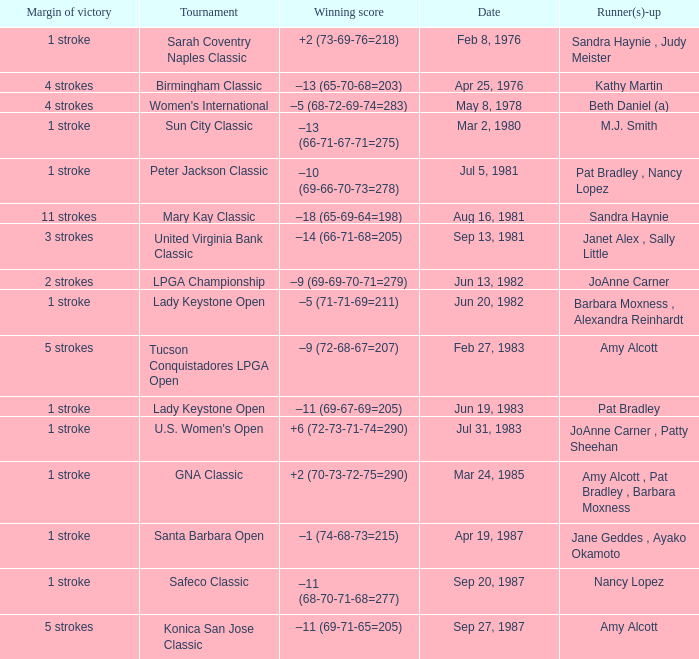What is the winning score when the tournament is safeco classic? –11 (68-70-71-68=277). 